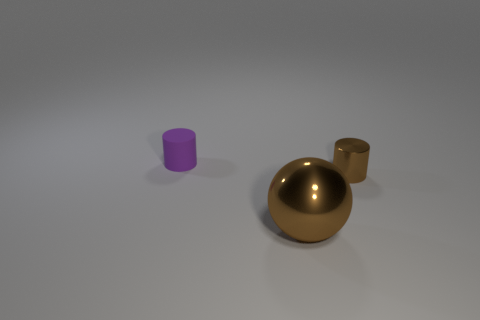Add 1 blue matte things. How many objects exist? 4 Subtract all balls. How many objects are left? 2 Subtract all big objects. Subtract all shiny balls. How many objects are left? 1 Add 2 tiny matte cylinders. How many tiny matte cylinders are left? 3 Add 1 small purple matte cylinders. How many small purple matte cylinders exist? 2 Subtract 0 blue cubes. How many objects are left? 3 